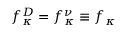Convert formula to latex. <formula><loc_0><loc_0><loc_500><loc_500>f _ { \kappa } ^ { D } = f _ { \kappa } ^ { \nu } \equiv f _ { \kappa }</formula> 